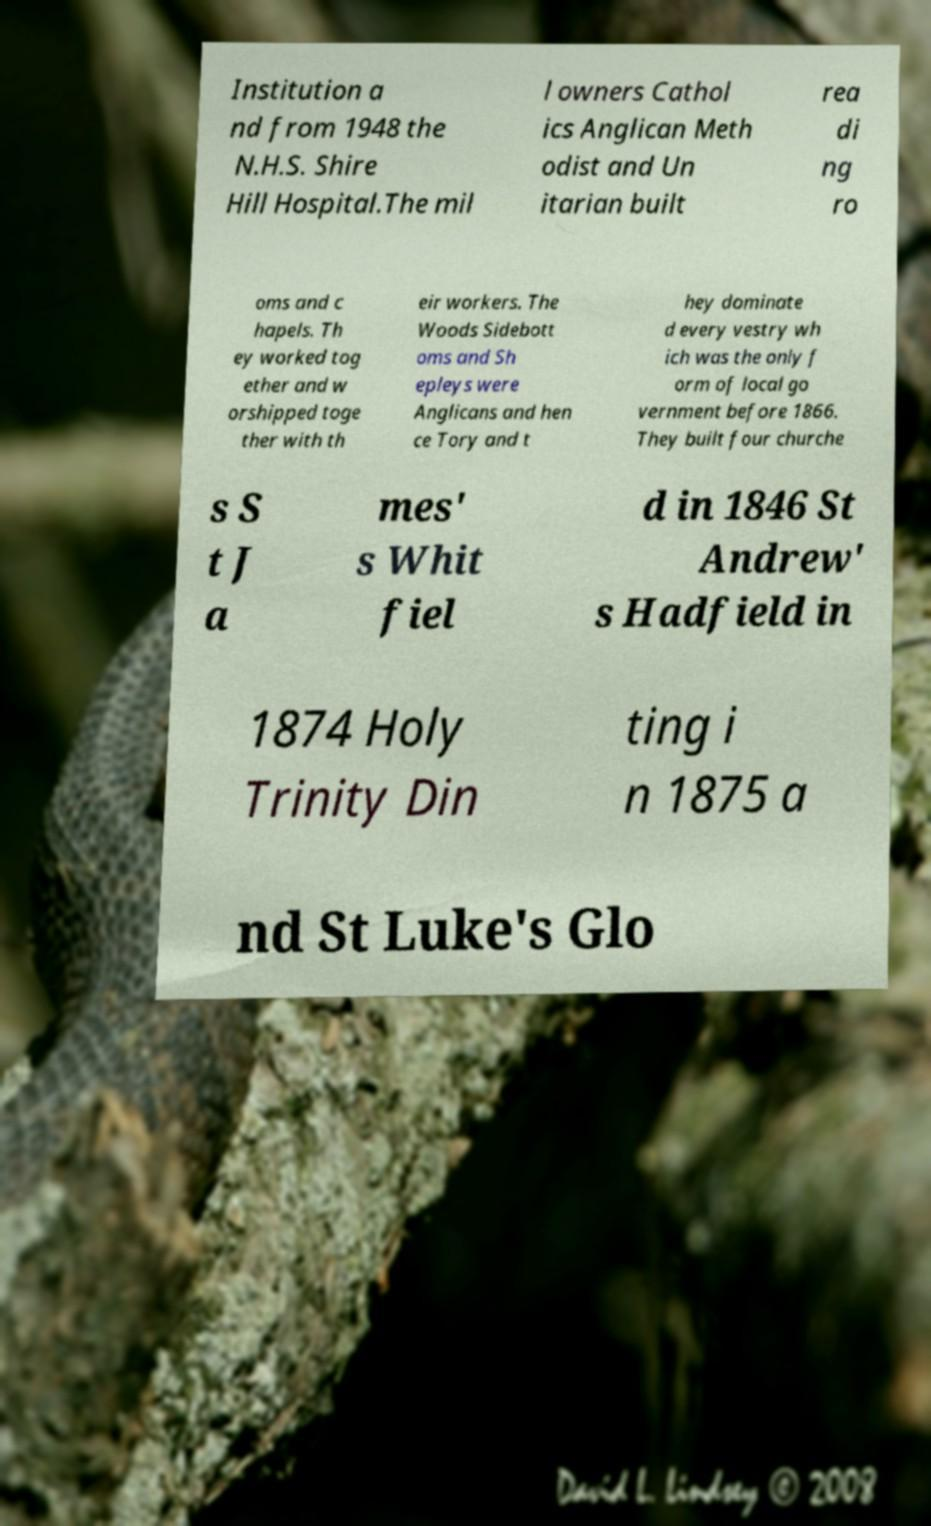For documentation purposes, I need the text within this image transcribed. Could you provide that? Institution a nd from 1948 the N.H.S. Shire Hill Hospital.The mil l owners Cathol ics Anglican Meth odist and Un itarian built rea di ng ro oms and c hapels. Th ey worked tog ether and w orshipped toge ther with th eir workers. The Woods Sidebott oms and Sh epleys were Anglicans and hen ce Tory and t hey dominate d every vestry wh ich was the only f orm of local go vernment before 1866. They built four churche s S t J a mes' s Whit fiel d in 1846 St Andrew' s Hadfield in 1874 Holy Trinity Din ting i n 1875 a nd St Luke's Glo 